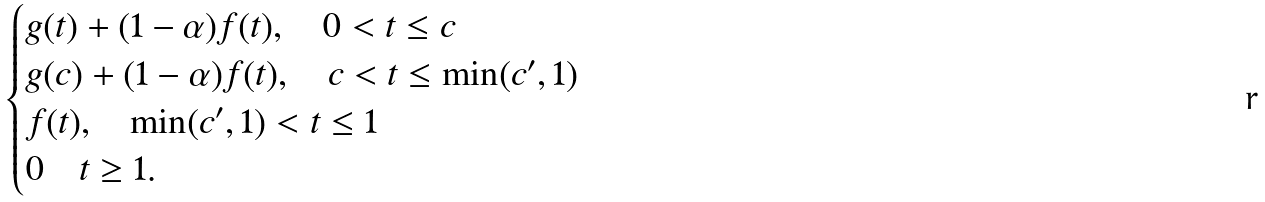<formula> <loc_0><loc_0><loc_500><loc_500>\begin{cases} g ( t ) + ( 1 - \alpha ) f ( t ) , \quad 0 < t \leq c \\ g ( c ) + ( 1 - \alpha ) f ( t ) , \quad c < t \leq \min ( c ^ { \prime } , 1 ) \\ f ( t ) , \quad \min ( c ^ { \prime } , 1 ) < t \leq 1 \\ 0 \quad t \geq 1 . \end{cases}</formula> 